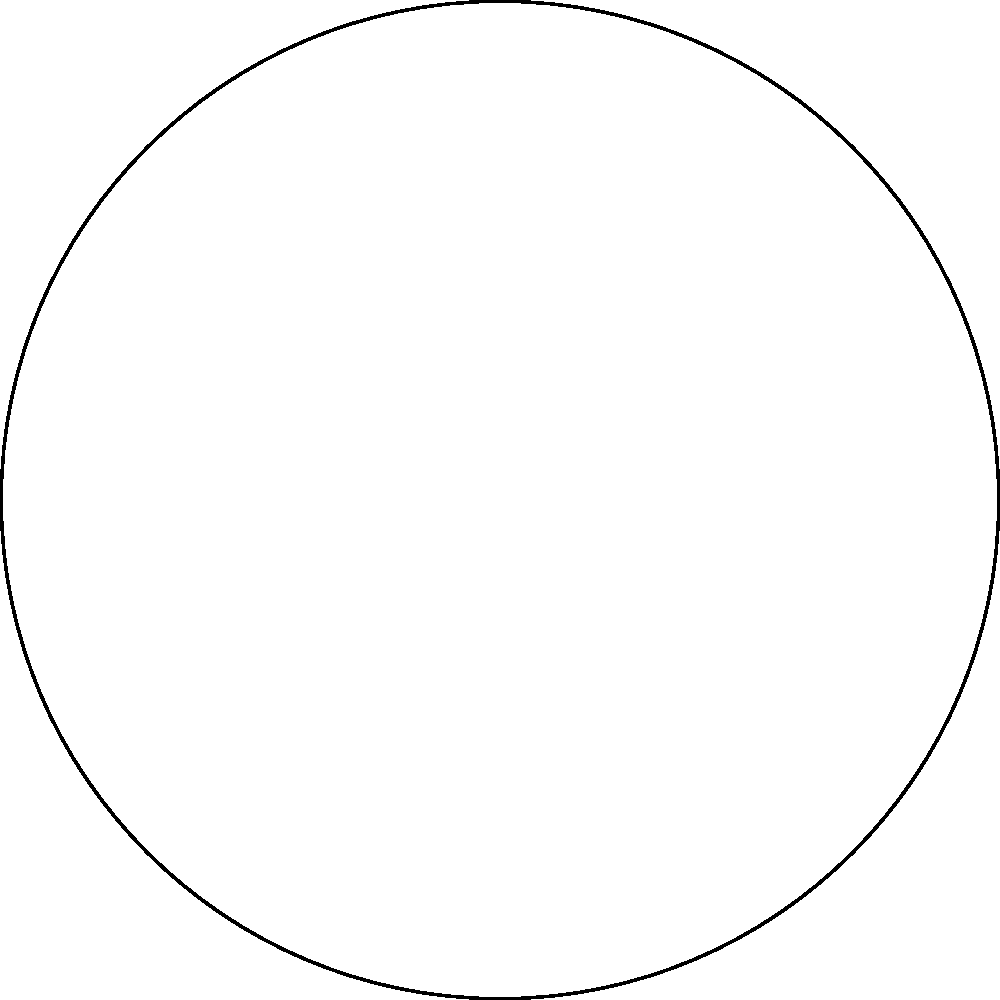In the polar clock diagram representing a caregiver's daily routine, which activity is scheduled to start at 3 PM and last for 3 hours? To answer this question, we need to analyze the polar clock diagram:

1. The diagram shows a 24-hour clock, with each hour marked around the circle.
2. There are four colored segments representing different activities:
   - Red: Personal Care
   - Green: Medication
   - Blue: Meal Prep
   - Yellow: Social Activities
3. Each segment's position indicates the start time, and its angular size represents the duration.
4. We need to find the activity that starts at 3 PM (15:00) and lasts for 3 hours.
5. Looking at the diagram, we can see that the yellow segment starts at the 3 PM (15:00) position.
6. The yellow segment spans 3 hours, ending at 6 PM (18:00).
7. The legend indicates that the yellow segment represents "Social Activities".

Therefore, the activity scheduled to start at 3 PM and last for 3 hours is Social Activities.
Answer: Social Activities 